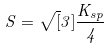<formula> <loc_0><loc_0><loc_500><loc_500>S = \sqrt { [ } 3 ] { \frac { K _ { s p } } { 4 } }</formula> 